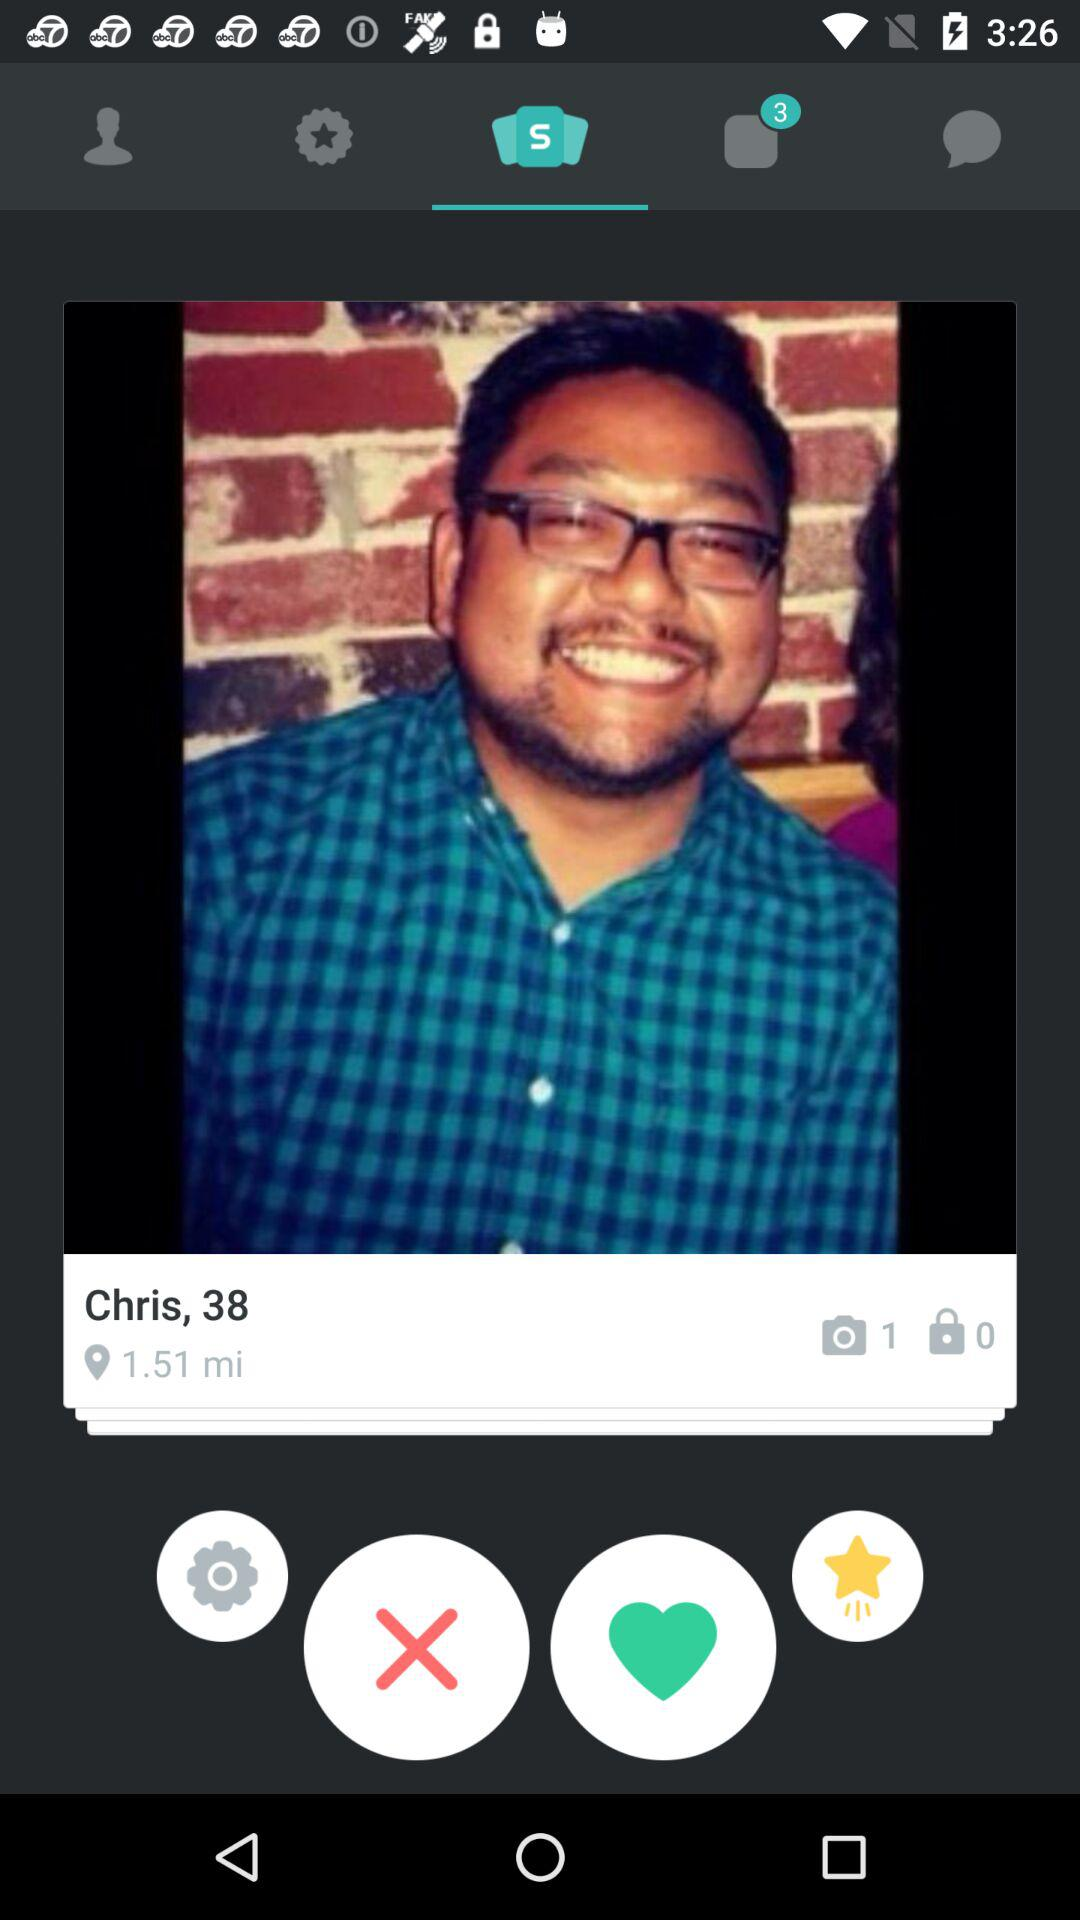What is the name of the person? The name of the person is Chris. 